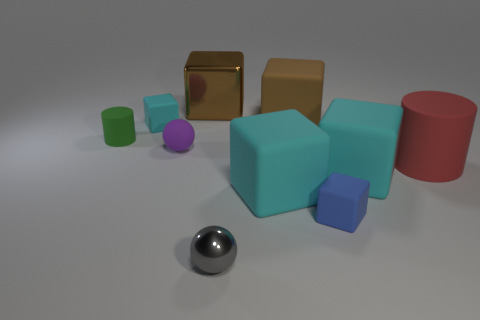There is a shiny block; is its color the same as the large matte object behind the big rubber cylinder?
Provide a short and direct response. Yes. There is a matte thing in front of the large cyan rubber object that is on the left side of the big brown object right of the gray thing; how big is it?
Provide a succinct answer. Small. What number of tiny rubber objects are in front of the tiny green matte object?
Your answer should be very brief. 2. Is the number of large matte cylinders behind the brown rubber cube the same as the number of brown shiny blocks?
Give a very brief answer. No. What number of things are either small gray spheres or big cylinders?
Ensure brevity in your answer.  2. Is there any other thing that is the same shape as the big red rubber object?
Keep it short and to the point. Yes. There is a big rubber thing behind the small matte thing to the left of the small cyan cube; what shape is it?
Offer a terse response. Cube. What shape is the brown thing that is made of the same material as the small cyan block?
Ensure brevity in your answer.  Cube. What is the size of the cyan block that is on the left side of the big brown metal block behind the tiny matte cylinder?
Ensure brevity in your answer.  Small. What is the shape of the green rubber thing?
Your response must be concise. Cylinder. 